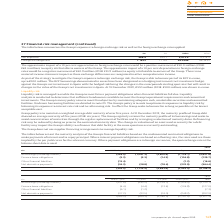According to Intu Properties's financial document, What is the net exposure to foreign exchange risk (euro) in 2019? According to the financial document, 468.9 (in millions). The relevant text states: "Net exposure 468.9 555.7 5,072.4 6,274.5..." Also, What is the net exposure to foreign exchange risk (indian rupee) in 2018? According to the financial document, 6,274.5 (in millions). The relevant text states: "Net exposure 468.9 555.7 5,072.4 6,274.5..." Also, What is the net exposure to foreign exchange risk (euro) in 2018? According to the financial document, 555.7 (in millions). The relevant text states: "Net exposure 468.9 555.7 5,072.4 6,274.5..." Also, can you calculate: What is the change in the positive movement of money to equity attributable to owners of the Group when there is a 10 per cent appreciation in foreign exchange rates from 2018 to 2019? Based on the calculation: 50.0-63.4, the result is -13.4 (in millions). This is based on the information: "n exchange rates would be a positive movement of £50.0 million (2018: £63.4 million) to equity attributable to owners of the Group. The approximate impact d be a positive movement of £50.0 million (20..." The key data points involved are: 50.0, 63.4. Also, can you calculate: What is the change in the negative movement of money to equity attributable to owners of the Group when there is a 10 per cent depreciation in foreign exchange rates from 2018 to 2019? Based on the calculation: 40.9-51.9, the result is -11 (in millions). This is based on the information: "n exchange rates would be a negative movement of £40.9 million (2018: £51.9 million) to equity attributable to owners of the Group. There is no material i d be a negative movement of £40.9 million (20..." The key data points involved are: 40.9, 51.9. Also, can you calculate: What is the percentage change in the amount drawn in euros from 2018 to 2019? I cannot find a specific answer to this question in the financial document. 